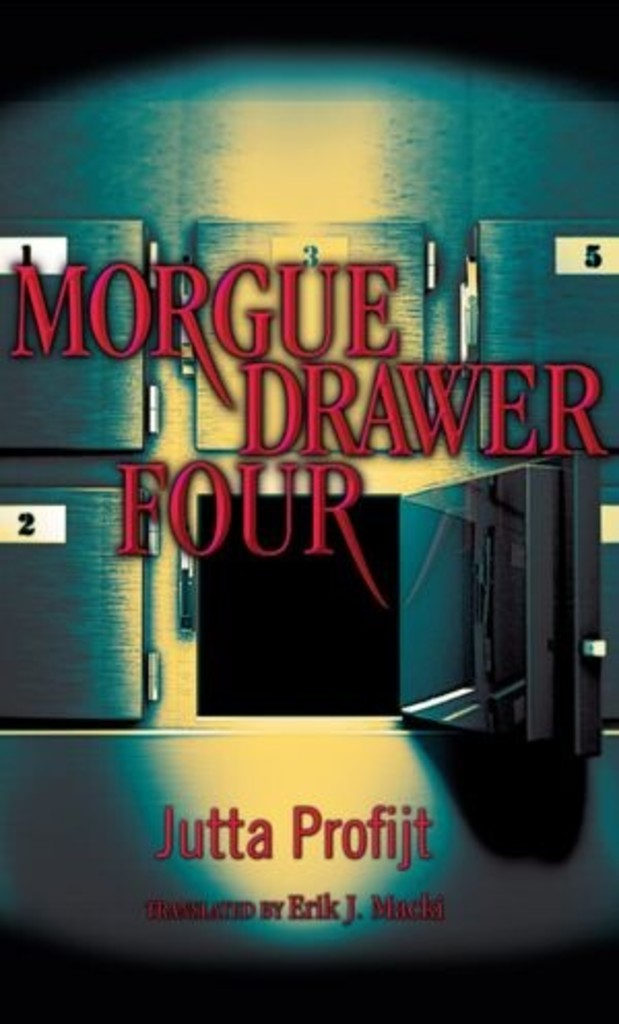How does the visual design of this cover contribute to the mood or theme of the book? The cover design of 'Morgue Drawer Four' significantly enhances the book's overall mood by using dark colors and a shadowy morgue with sequentially numbered doors, creating an atmosphere of mystery and foreboding. This visual approach not only grabs the attention of potential readers but also sets the tone of mystery and suspense, prepping the reader for a chilling narrative likely filled with unexpected twists and dark secrets. 